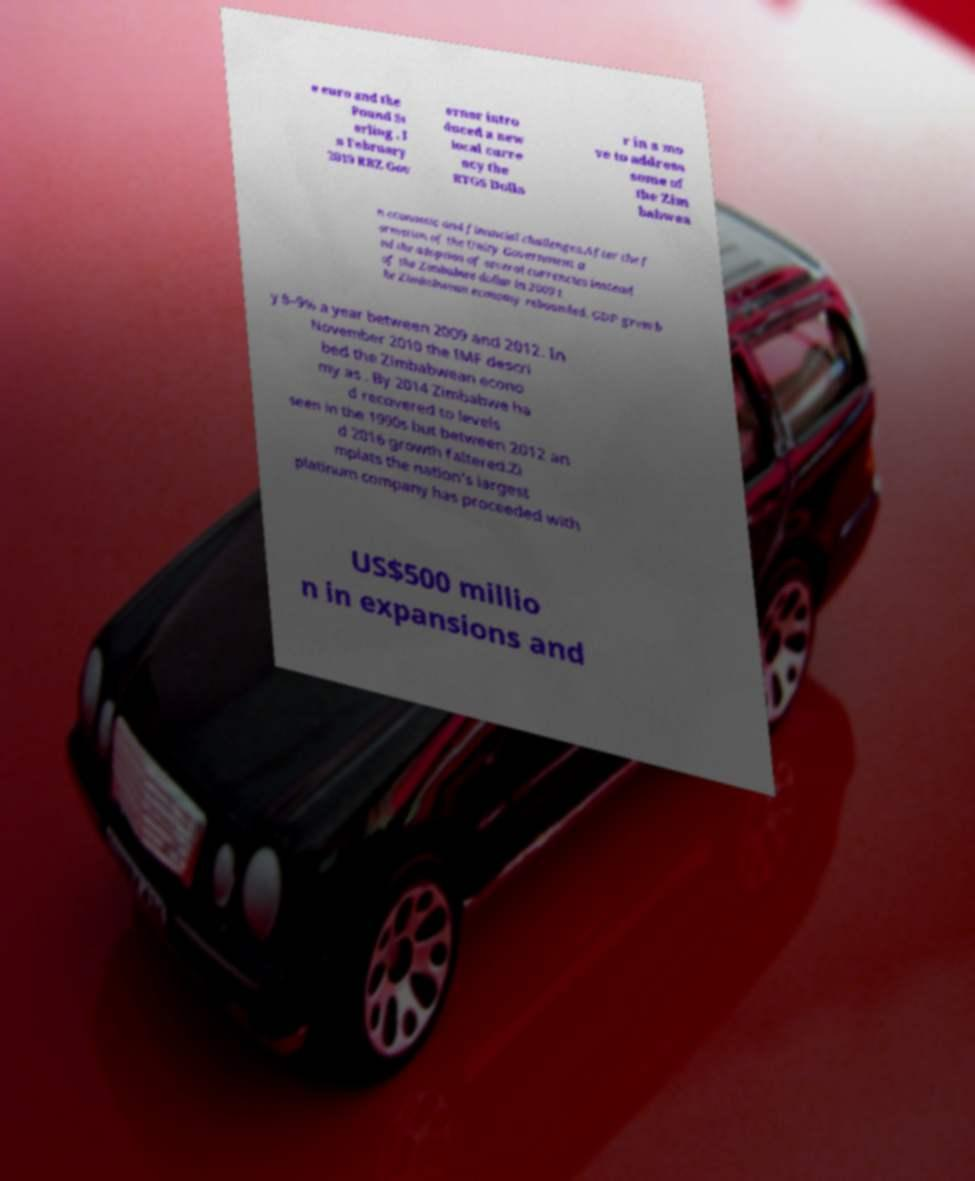There's text embedded in this image that I need extracted. Can you transcribe it verbatim? e euro and the Pound St erling . I n February 2019 RBZ Gov ernor intro duced a new local curre ncy the RTGS Dolla r in a mo ve to address some of the Zim babwea n economic and financial challenges.After the f ormation of the Unity Government a nd the adoption of several currencies instead of the Zimbabwe dollar in 2009 t he Zimbabwean economy rebounded. GDP grew b y 8–9% a year between 2009 and 2012. In November 2010 the IMF descri bed the Zimbabwean econo my as . By 2014 Zimbabwe ha d recovered to levels seen in the 1990s but between 2012 an d 2016 growth faltered.Zi mplats the nation's largest platinum company has proceeded with US$500 millio n in expansions and 